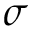<formula> <loc_0><loc_0><loc_500><loc_500>\sigma</formula> 